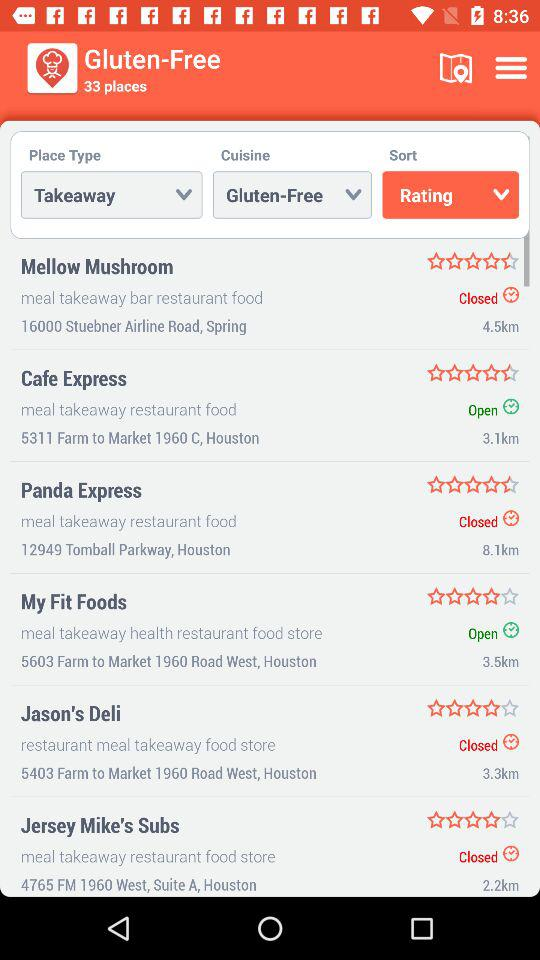What is the address of "Jason's Deli"? The address is 5403 Farm to Market 1960 Road West, Houston. 